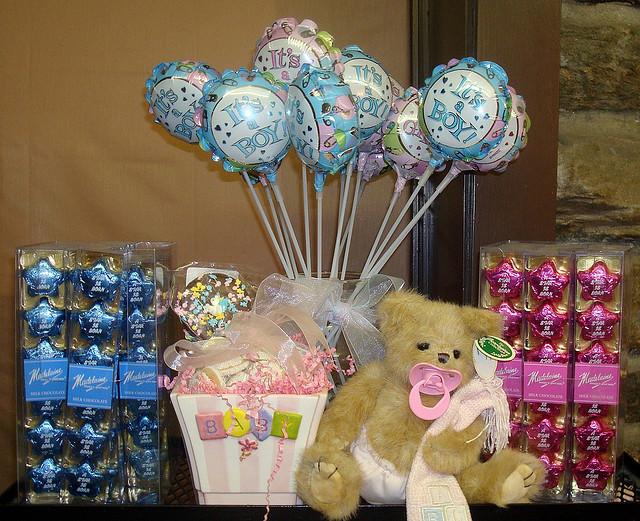What do the balloons say?
Quick response, please. It's boy. What is in the bear's mouth?
Answer briefly. Pacifier. Would this work for a boy's room?
Short answer required. Yes. How many stuffed animals are there?
Short answer required. 1. 